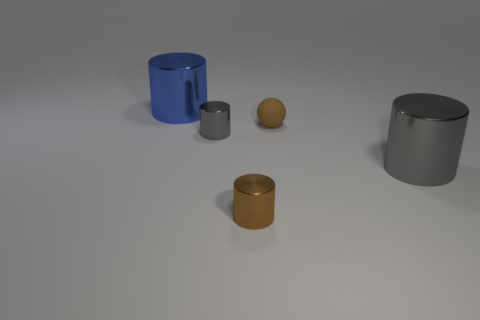Subtract all gray cylinders. How many were subtracted if there are1gray cylinders left? 1 Add 5 big blue cylinders. How many objects exist? 10 Subtract all cylinders. How many objects are left? 1 Subtract 1 blue cylinders. How many objects are left? 4 Subtract all brown balls. Subtract all large blue metal cylinders. How many objects are left? 3 Add 2 rubber things. How many rubber things are left? 3 Add 5 brown spheres. How many brown spheres exist? 6 